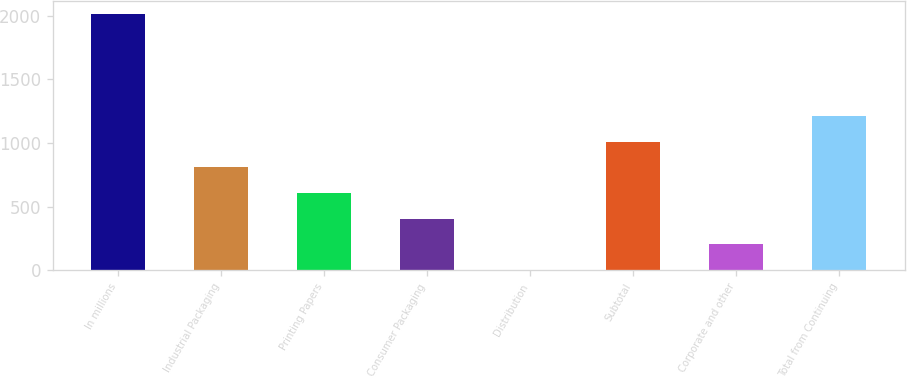<chart> <loc_0><loc_0><loc_500><loc_500><bar_chart><fcel>In millions<fcel>Industrial Packaging<fcel>Printing Papers<fcel>Consumer Packaging<fcel>Distribution<fcel>Subtotal<fcel>Corporate and other<fcel>Total from Continuing<nl><fcel>2010<fcel>807<fcel>606.5<fcel>406<fcel>5<fcel>1007.5<fcel>205.5<fcel>1208<nl></chart> 